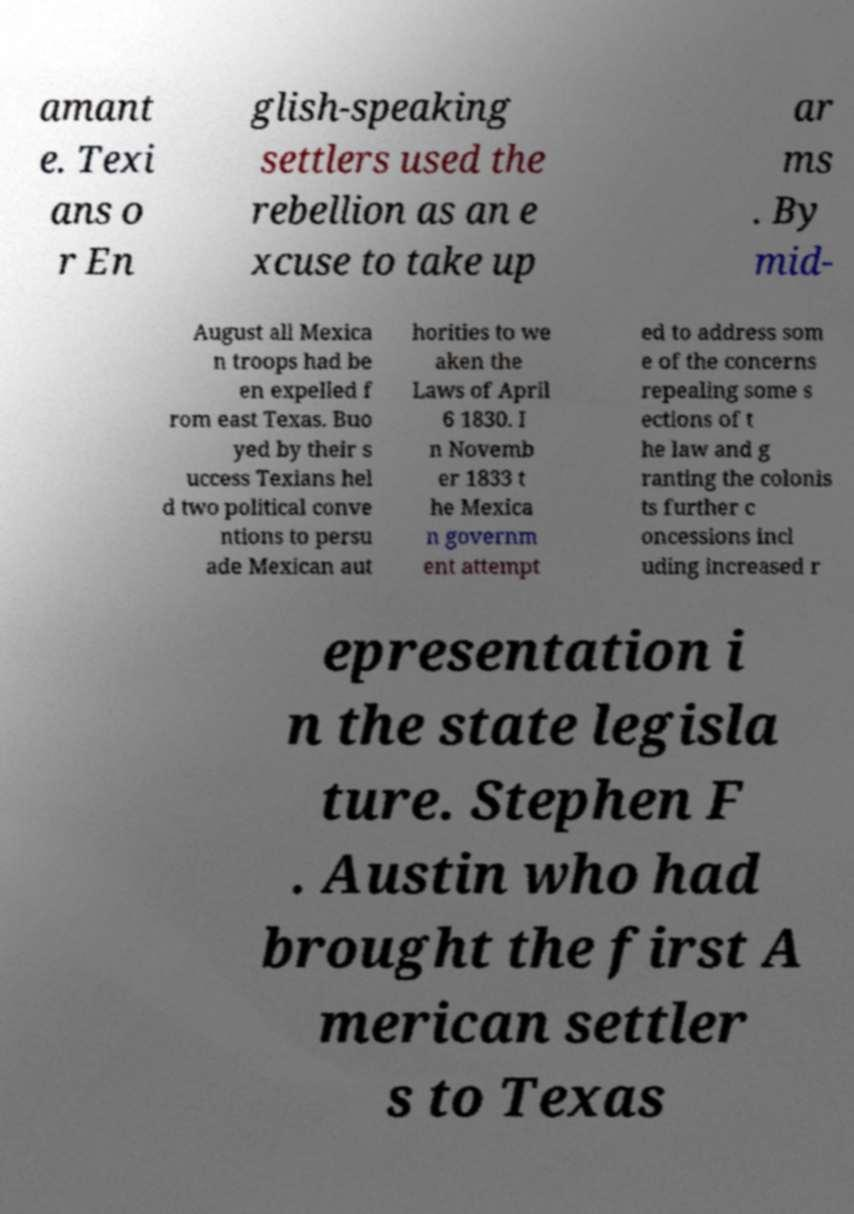Please read and relay the text visible in this image. What does it say? amant e. Texi ans o r En glish-speaking settlers used the rebellion as an e xcuse to take up ar ms . By mid- August all Mexica n troops had be en expelled f rom east Texas. Buo yed by their s uccess Texians hel d two political conve ntions to persu ade Mexican aut horities to we aken the Laws of April 6 1830. I n Novemb er 1833 t he Mexica n governm ent attempt ed to address som e of the concerns repealing some s ections of t he law and g ranting the colonis ts further c oncessions incl uding increased r epresentation i n the state legisla ture. Stephen F . Austin who had brought the first A merican settler s to Texas 